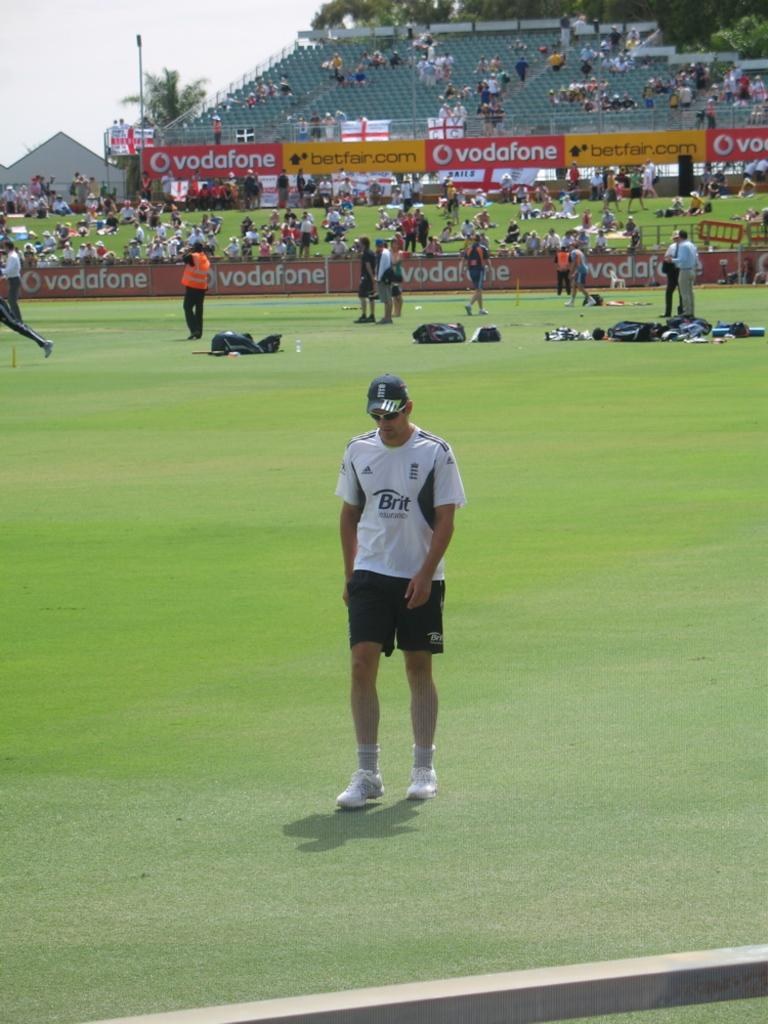What type of vegetation is present in the image? There is grass in the image. Can you describe the people in the image? There are people in the image. What architectural feature can be seen in the image? There is a wall in the image. What is visible in the background of the image? There are steps, chairs, and trees in the background of the image. Are there any people behind the wall? Yes, there are people behind the wall. What type of joke is being told by the trees in the background of the image? There are no jokes being told in the image, as it does not involve any comedic elements or dialogue. 